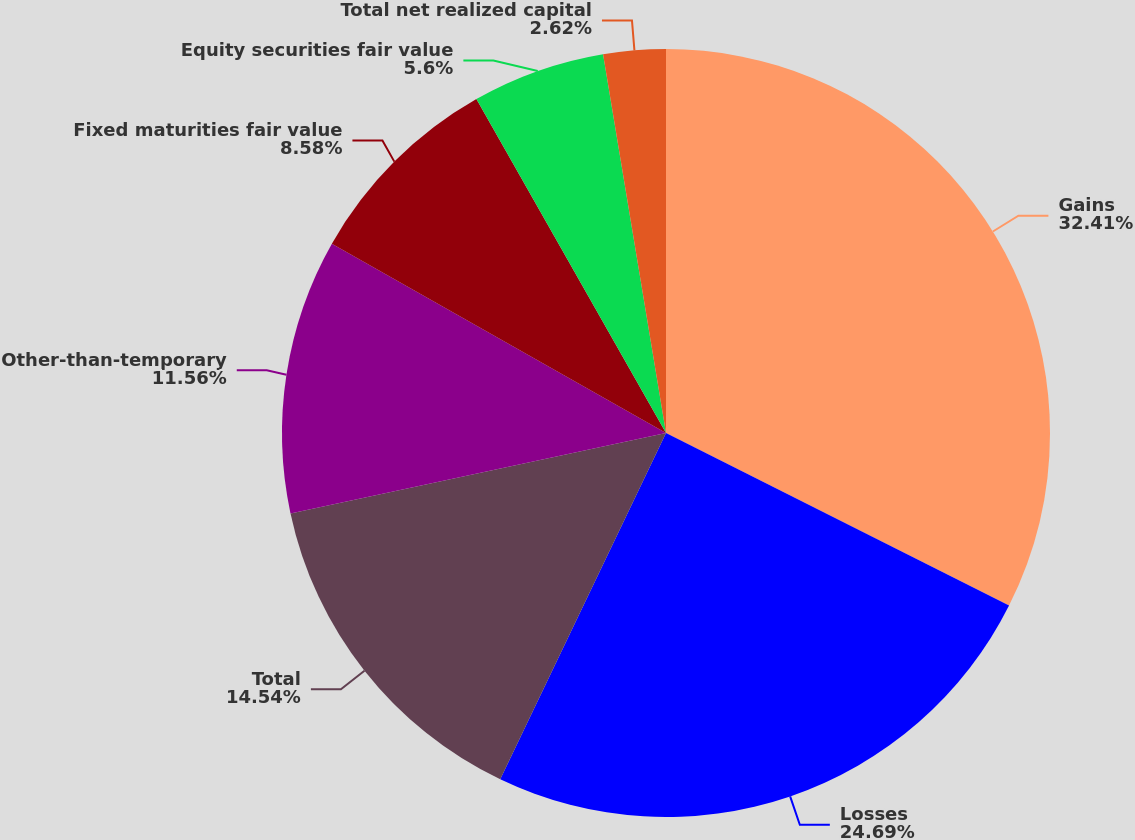Convert chart. <chart><loc_0><loc_0><loc_500><loc_500><pie_chart><fcel>Gains<fcel>Losses<fcel>Total<fcel>Other-than-temporary<fcel>Fixed maturities fair value<fcel>Equity securities fair value<fcel>Total net realized capital<nl><fcel>32.42%<fcel>24.69%<fcel>14.54%<fcel>11.56%<fcel>8.58%<fcel>5.6%<fcel>2.62%<nl></chart> 